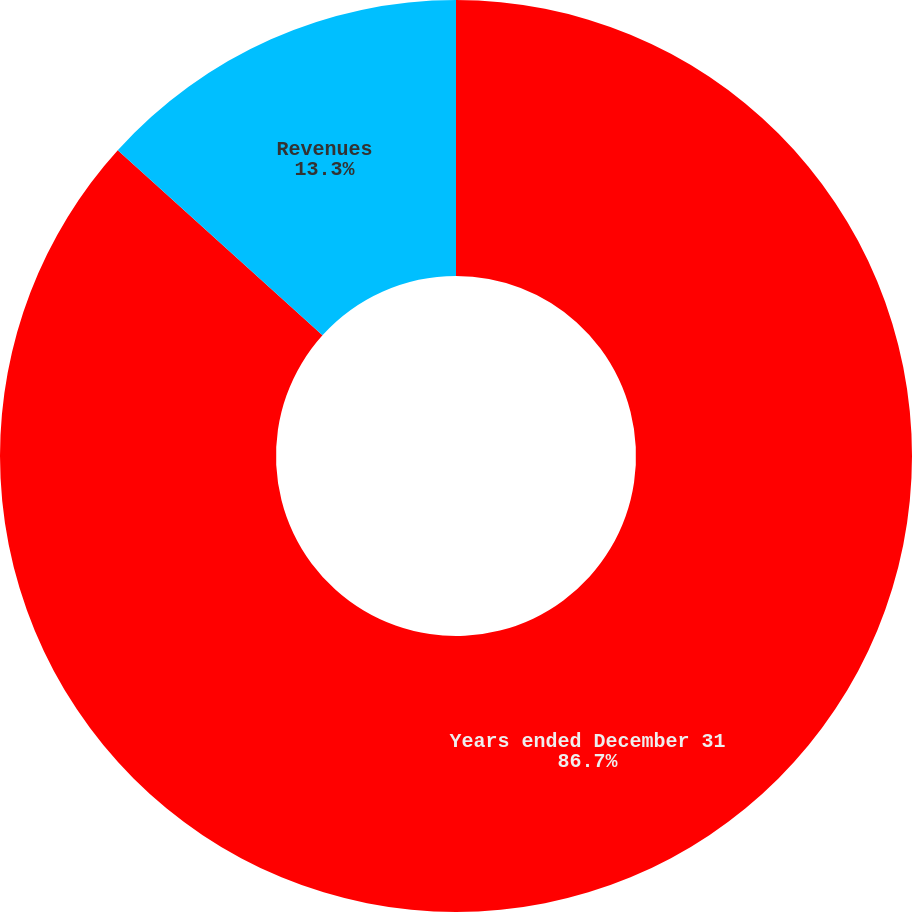<chart> <loc_0><loc_0><loc_500><loc_500><pie_chart><fcel>Years ended December 31<fcel>Revenues<nl><fcel>86.7%<fcel>13.3%<nl></chart> 